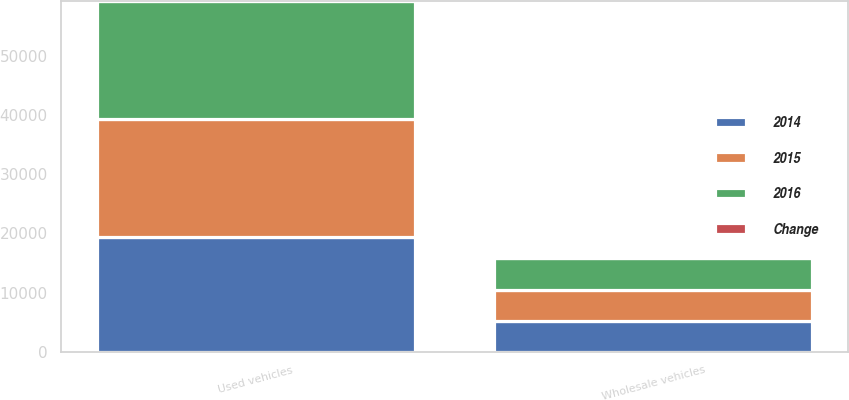Convert chart to OTSL. <chart><loc_0><loc_0><loc_500><loc_500><stacked_bar_chart><ecel><fcel>Used vehicles<fcel>Wholesale vehicles<nl><fcel>2016<fcel>19917<fcel>5327<nl><fcel>Change<fcel>0.1<fcel>1<nl><fcel>2015<fcel>19897<fcel>5273<nl><fcel>2014<fcel>19408<fcel>5160<nl></chart> 